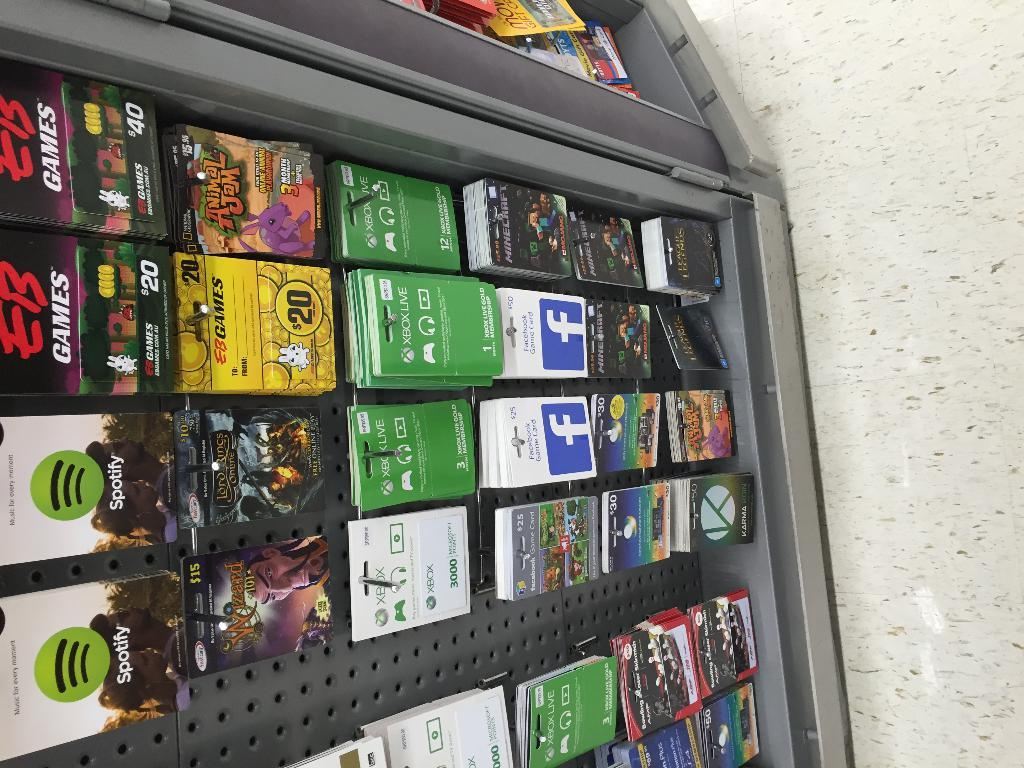<image>
Summarize the visual content of the image. A rack of gift cards includes some for Spotify and EB Games. 